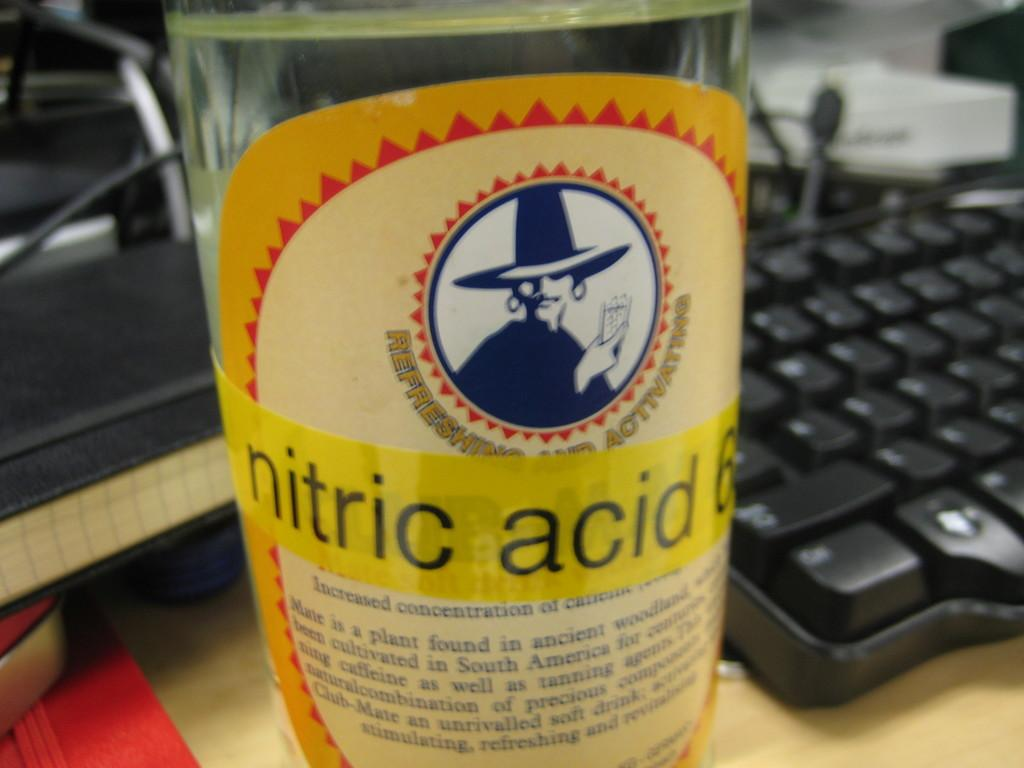What is contained in the bottle that is visible in the image? There is a bottle with a liquid in the image. What can be found on the bottle's surface? The bottle has a label. What electronic device is present in the image? There is a keyboard in the image. What type of surface are the other items placed on in the image? There are other items on a wooden board in the image. What type of behavior does the owner of the bottle exhibit in the image? There is no indication of an owner in the image, nor any behavior associated with the bottle. How is the bottle being transported in the image? The bottle is not being transported in the image; it is stationary on a surface. 